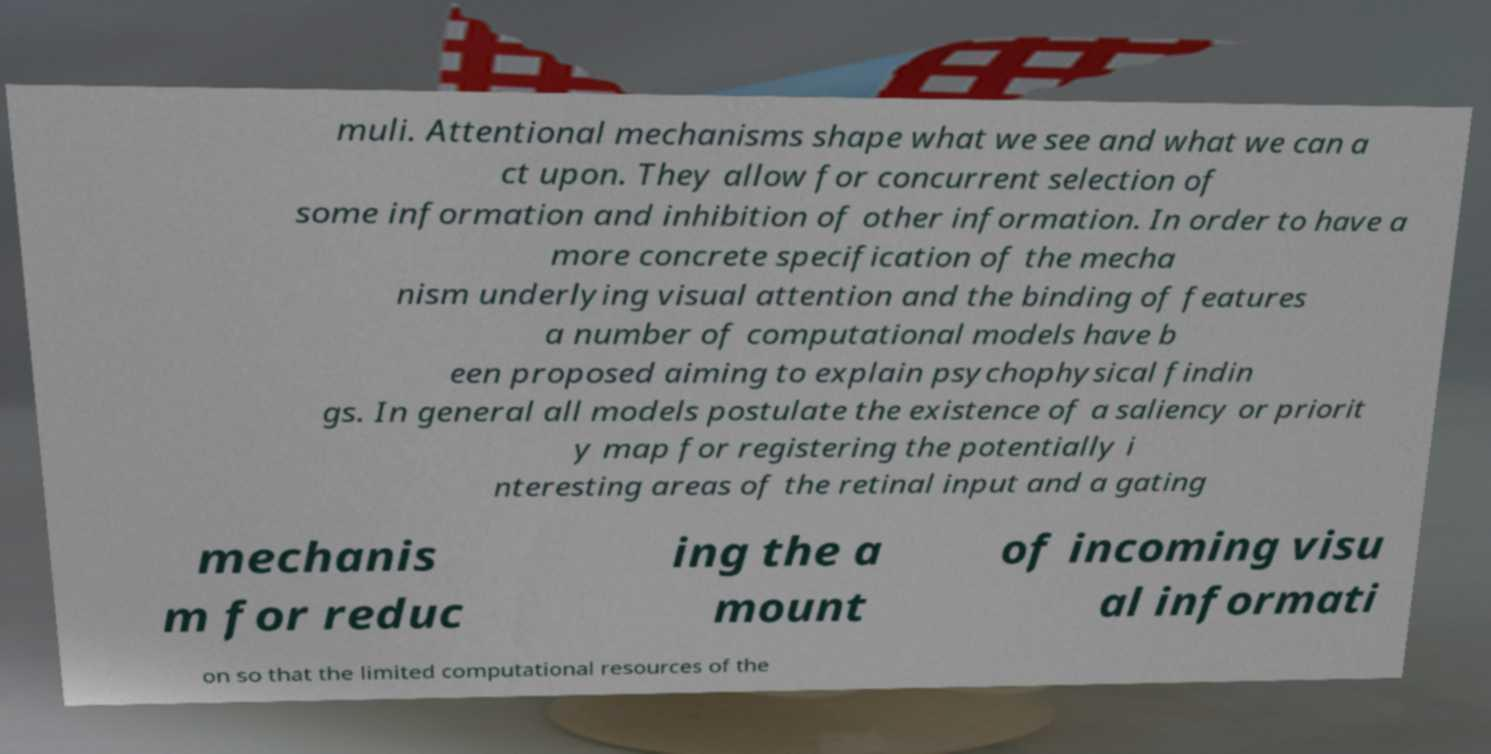Could you extract and type out the text from this image? muli. Attentional mechanisms shape what we see and what we can a ct upon. They allow for concurrent selection of some information and inhibition of other information. In order to have a more concrete specification of the mecha nism underlying visual attention and the binding of features a number of computational models have b een proposed aiming to explain psychophysical findin gs. In general all models postulate the existence of a saliency or priorit y map for registering the potentially i nteresting areas of the retinal input and a gating mechanis m for reduc ing the a mount of incoming visu al informati on so that the limited computational resources of the 